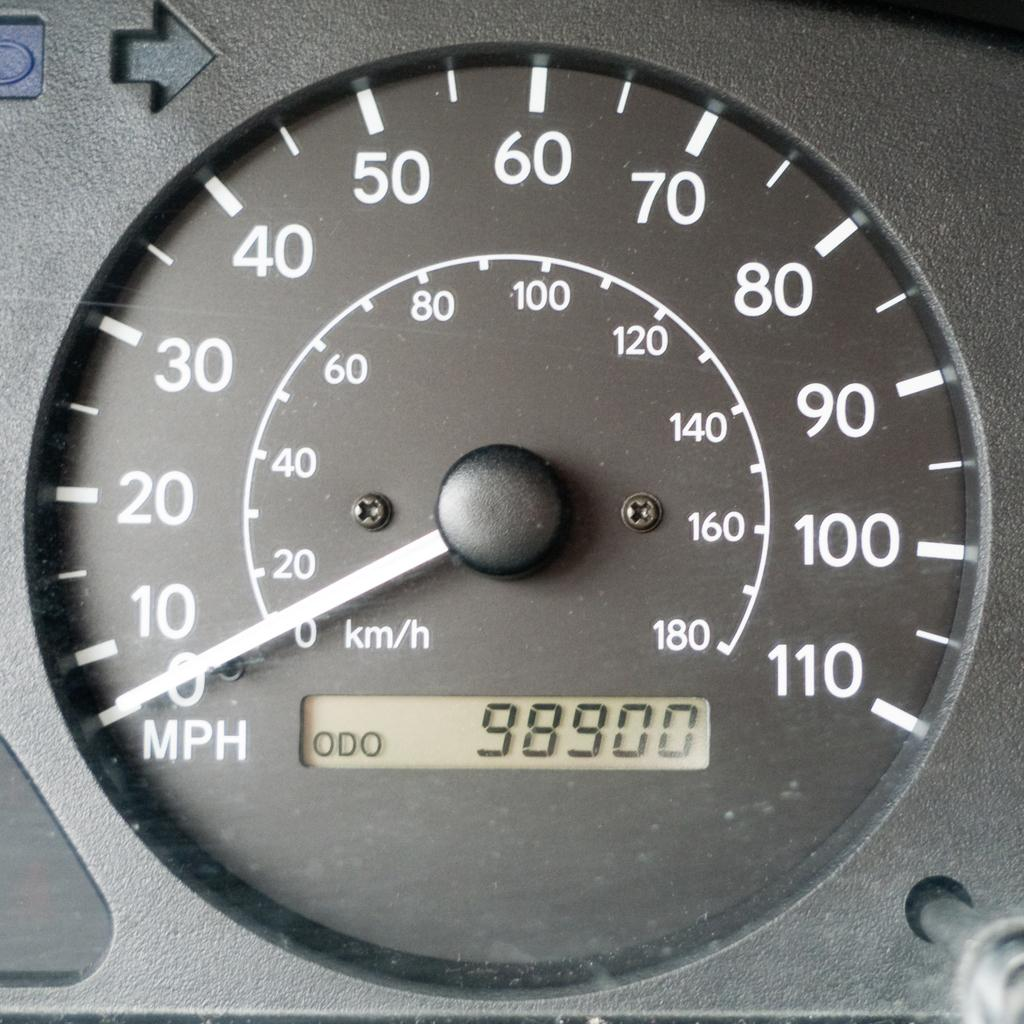What type of instrument is visible in the image? There is a speedometer in the image. How many pears are on the speedometer in the image? There are no pears present on the speedometer in the image. What type of town is depicted in the background of the image? There is no town depicted in the image; it only features a speedometer. 